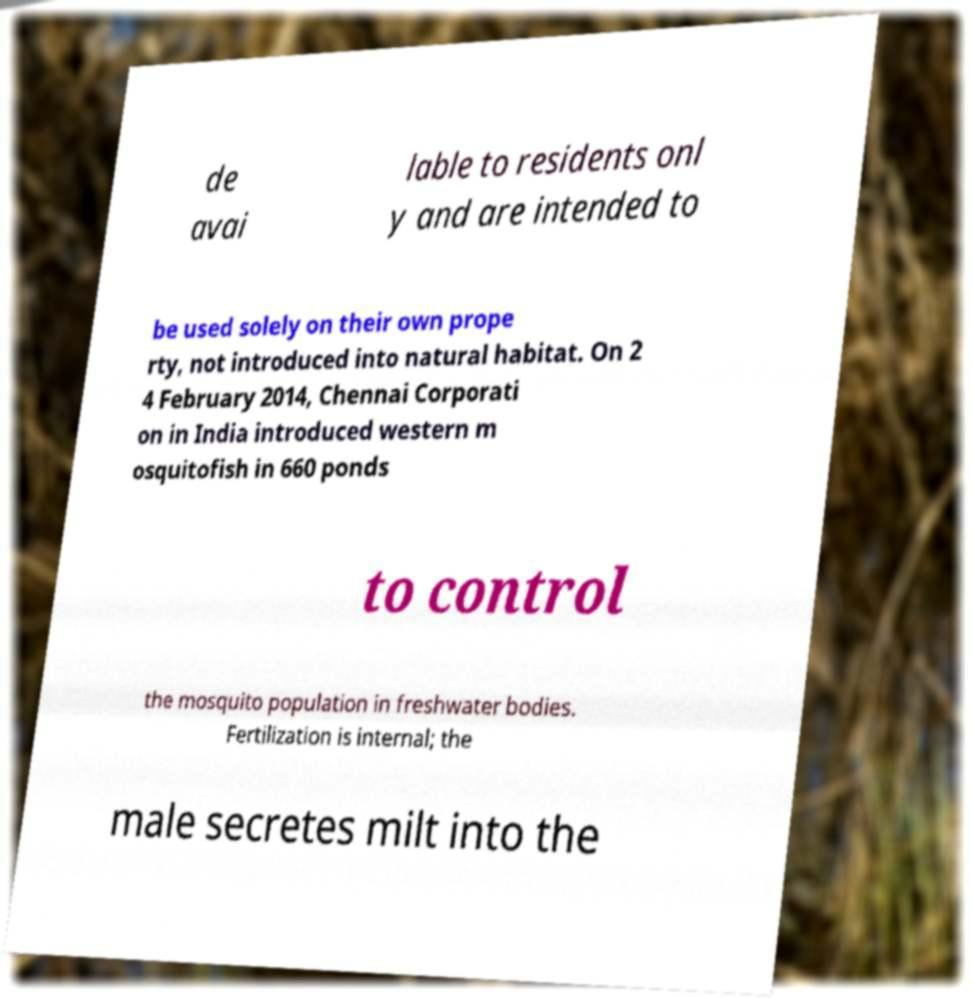Could you extract and type out the text from this image? de avai lable to residents onl y and are intended to be used solely on their own prope rty, not introduced into natural habitat. On 2 4 February 2014, Chennai Corporati on in India introduced western m osquitofish in 660 ponds to control the mosquito population in freshwater bodies. Fertilization is internal; the male secretes milt into the 